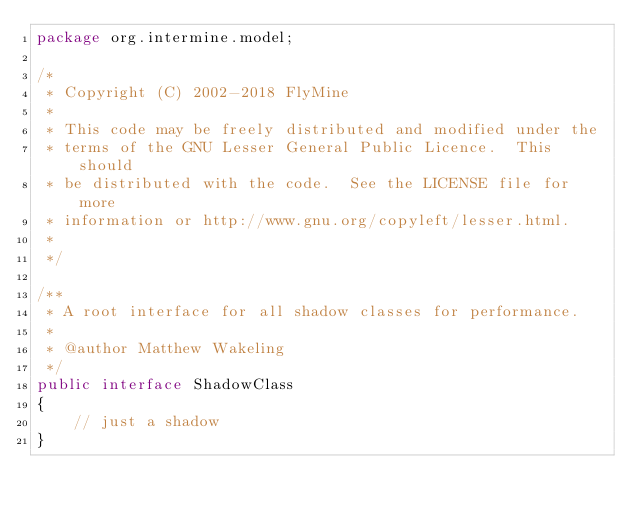<code> <loc_0><loc_0><loc_500><loc_500><_Java_>package org.intermine.model;

/*
 * Copyright (C) 2002-2018 FlyMine
 *
 * This code may be freely distributed and modified under the
 * terms of the GNU Lesser General Public Licence.  This should
 * be distributed with the code.  See the LICENSE file for more
 * information or http://www.gnu.org/copyleft/lesser.html.
 *
 */

/**
 * A root interface for all shadow classes for performance.
 *
 * @author Matthew Wakeling
 */
public interface ShadowClass
{
    // just a shadow
}
</code> 